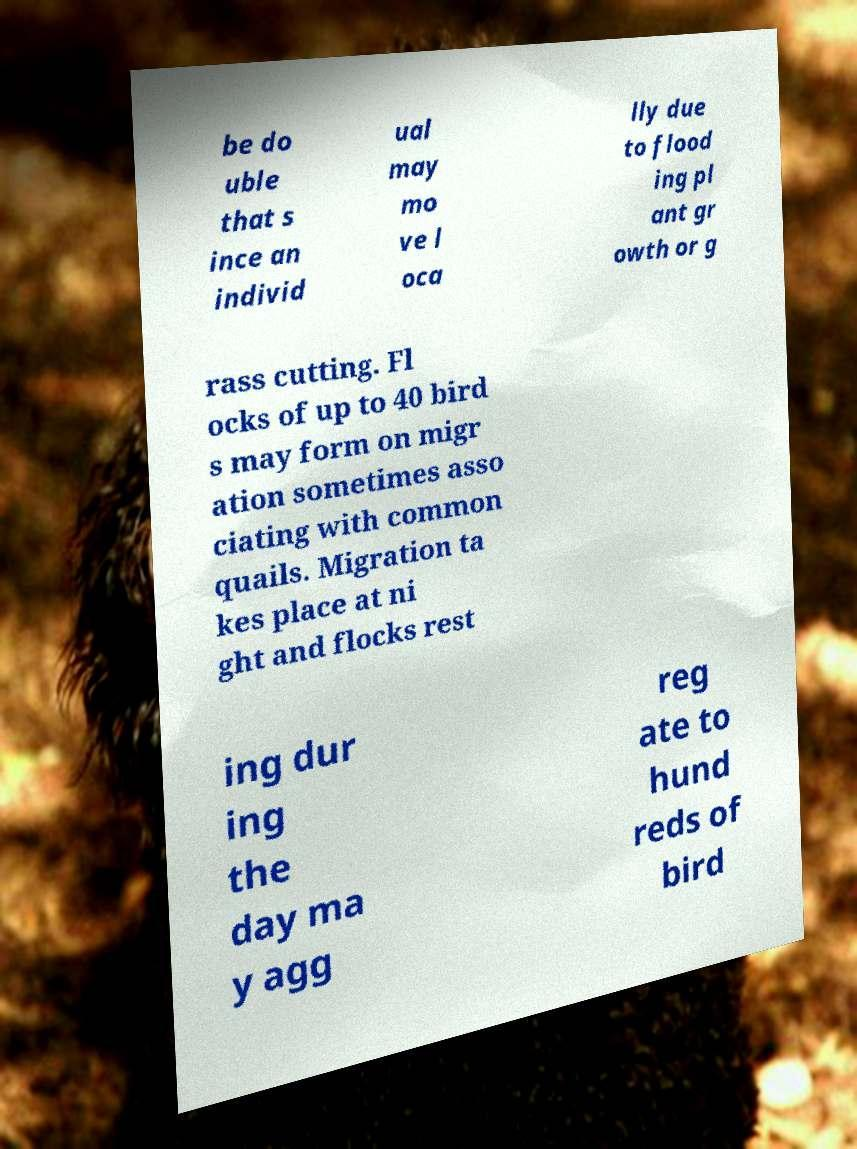Could you assist in decoding the text presented in this image and type it out clearly? be do uble that s ince an individ ual may mo ve l oca lly due to flood ing pl ant gr owth or g rass cutting. Fl ocks of up to 40 bird s may form on migr ation sometimes asso ciating with common quails. Migration ta kes place at ni ght and flocks rest ing dur ing the day ma y agg reg ate to hund reds of bird 